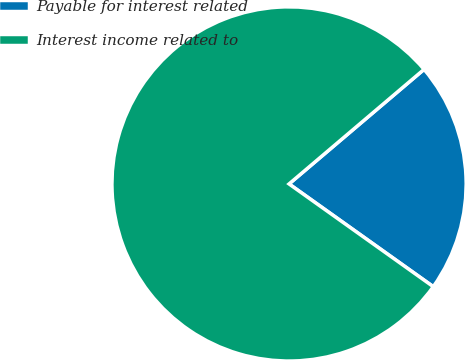Convert chart. <chart><loc_0><loc_0><loc_500><loc_500><pie_chart><fcel>Payable for interest related<fcel>Interest income related to<nl><fcel>21.05%<fcel>78.95%<nl></chart> 